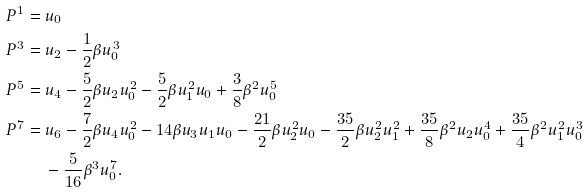Convert formula to latex. <formula><loc_0><loc_0><loc_500><loc_500>P ^ { 1 } & = u _ { 0 } \\ P ^ { 3 } & = u _ { 2 } - \frac { 1 } { 2 } \beta u _ { 0 } ^ { 3 } \\ P ^ { 5 } & = u _ { 4 } - \frac { 5 } { 2 } \beta u _ { 2 } u _ { 0 } ^ { 2 } - \frac { 5 } { 2 } \beta u _ { 1 } ^ { 2 } u _ { 0 } + \frac { 3 } { 8 } \beta ^ { 2 } u _ { 0 } ^ { 5 } \\ P ^ { 7 } & = u _ { 6 } - \frac { 7 } { 2 } \beta u _ { 4 } u _ { 0 } ^ { 2 } - 1 4 \beta u _ { 3 } u _ { 1 } u _ { 0 } - \frac { 2 1 } { 2 } \beta u _ { 2 } ^ { 2 } u _ { 0 } - \frac { 3 5 } { 2 } \beta u _ { 2 } ^ { 2 } u _ { 1 } ^ { 2 } + \frac { 3 5 } { 8 } \beta ^ { 2 } u _ { 2 } u _ { 0 } ^ { 4 } + \frac { 3 5 } { 4 } \beta ^ { 2 } u _ { 1 } ^ { 2 } u _ { 0 } ^ { 3 } \\ & \quad \, - \frac { 5 } { 1 6 } \beta ^ { 3 } u _ { 0 } ^ { 7 } .</formula> 